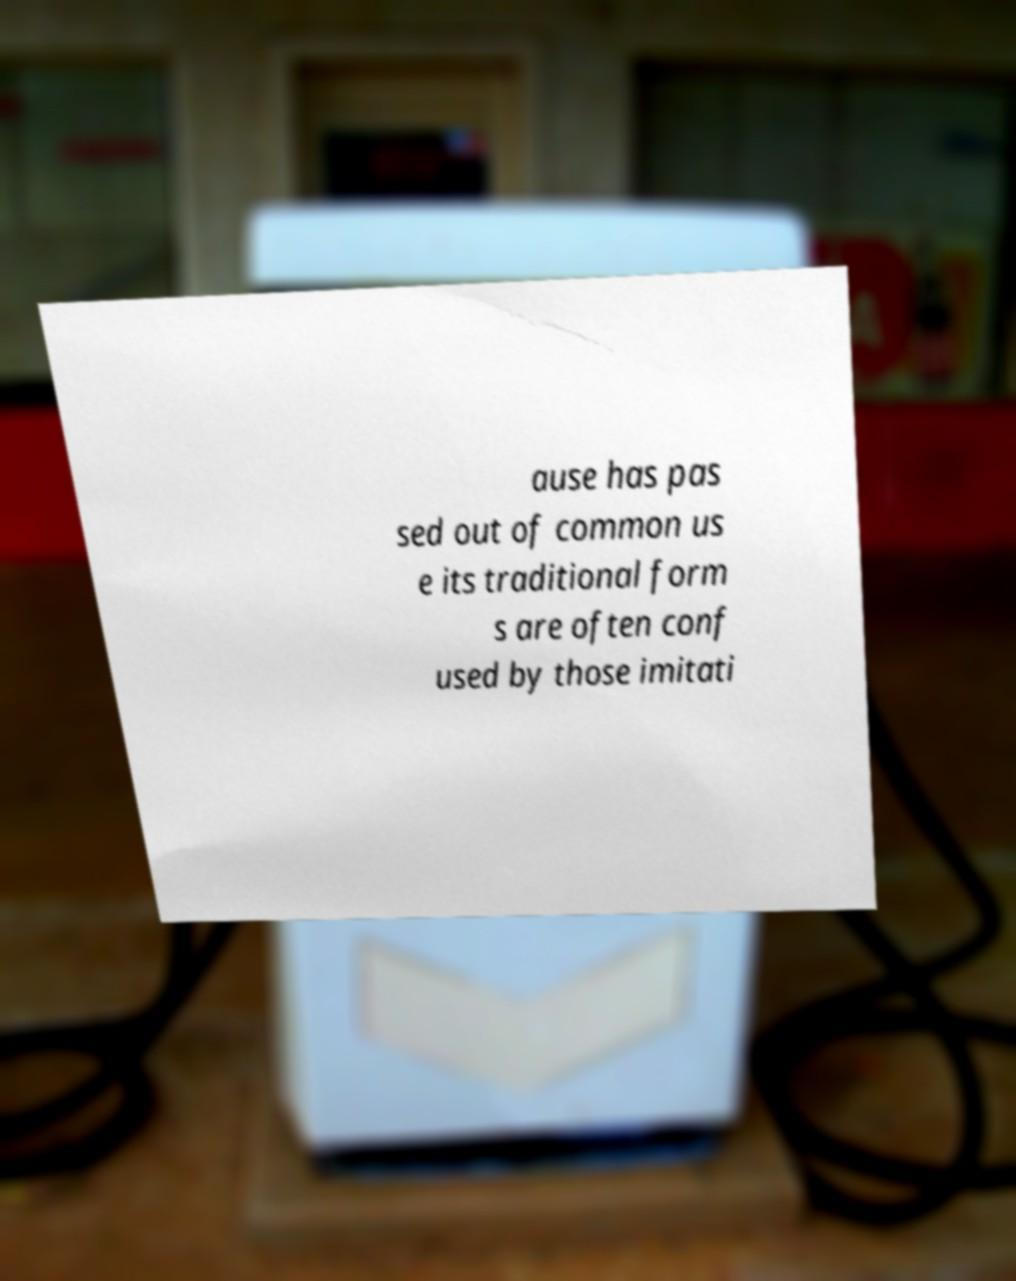I need the written content from this picture converted into text. Can you do that? ause has pas sed out of common us e its traditional form s are often conf used by those imitati 